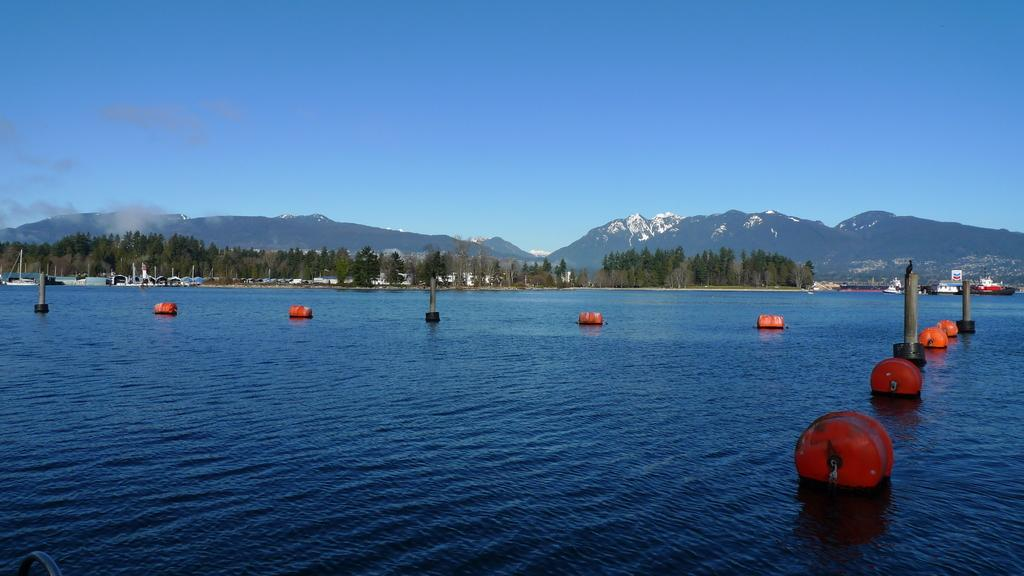What is the primary element in the image? There is water in the image. What can be seen floating in the water? There are orange color objects in the water. What type of vegetation is visible in the image? There are trees visible in the image. What type of geographical feature can be seen in the image? There are mountains in the image. What color is the sky in the image? The sky is blue at the top of the image. How many times does the mouth smash the waves in the image? There is no mouth or waves present in the image, so this action cannot be observed. 